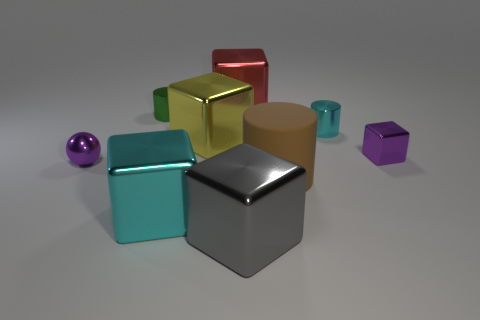Subtract all large yellow metal blocks. How many blocks are left? 4 Subtract 1 cylinders. How many cylinders are left? 2 Subtract all gray cubes. How many cubes are left? 4 Subtract all balls. How many objects are left? 8 Subtract 1 red blocks. How many objects are left? 8 Subtract all purple cylinders. Subtract all green balls. How many cylinders are left? 3 Subtract all cyan metallic balls. Subtract all cyan metal objects. How many objects are left? 7 Add 9 small cyan shiny cylinders. How many small cyan shiny cylinders are left? 10 Add 1 small brown balls. How many small brown balls exist? 1 